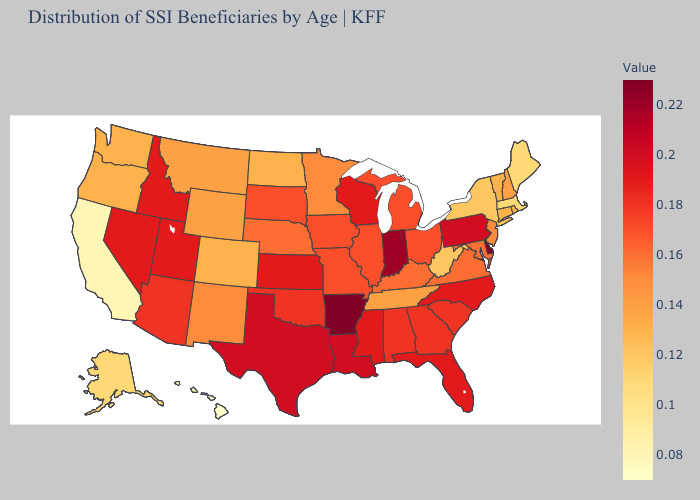Among the states that border Arizona , does Colorado have the lowest value?
Write a very short answer. No. Among the states that border Arkansas , does Louisiana have the highest value?
Keep it brief. Yes. Which states have the lowest value in the South?
Keep it brief. West Virginia. Among the states that border Arizona , does California have the lowest value?
Quick response, please. Yes. Among the states that border Ohio , which have the highest value?
Write a very short answer. Indiana. 